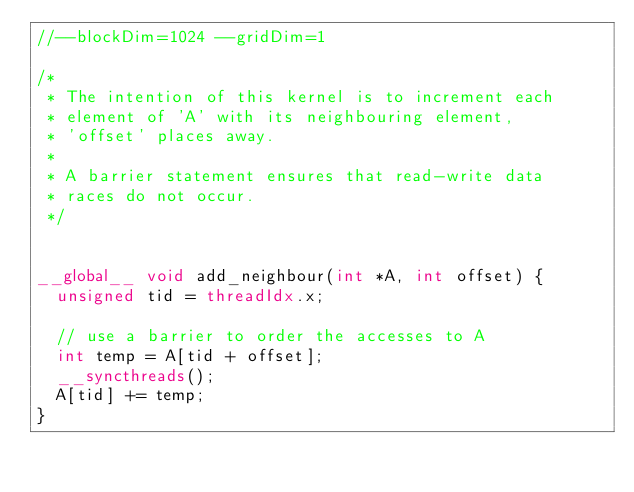Convert code to text. <code><loc_0><loc_0><loc_500><loc_500><_Cuda_>//--blockDim=1024 --gridDim=1

/* 
 * The intention of this kernel is to increment each
 * element of 'A' with its neighbouring element,
 * 'offset' places away.
 *
 * A barrier statement ensures that read-write data
 * races do not occur.
 */


__global__ void add_neighbour(int *A, int offset) { 
  unsigned tid = threadIdx.x; 

  // use a barrier to order the accesses to A
  int temp = A[tid + offset];
  __syncthreads();
  A[tid] += temp;
}

</code> 